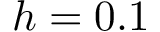<formula> <loc_0><loc_0><loc_500><loc_500>h = 0 . 1</formula> 